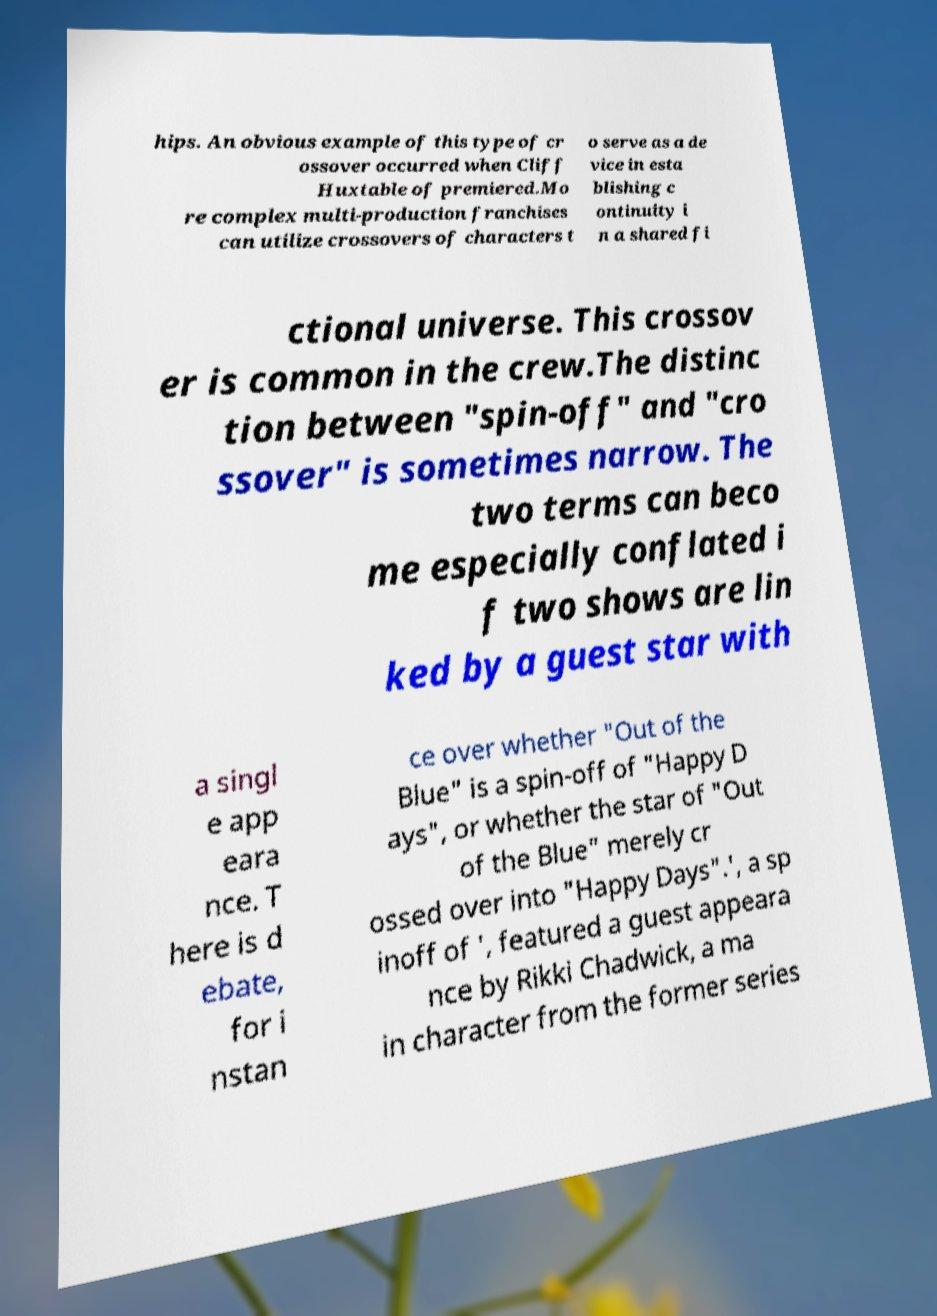I need the written content from this picture converted into text. Can you do that? hips. An obvious example of this type of cr ossover occurred when Cliff Huxtable of premiered.Mo re complex multi-production franchises can utilize crossovers of characters t o serve as a de vice in esta blishing c ontinuity i n a shared fi ctional universe. This crossov er is common in the crew.The distinc tion between "spin-off" and "cro ssover" is sometimes narrow. The two terms can beco me especially conflated i f two shows are lin ked by a guest star with a singl e app eara nce. T here is d ebate, for i nstan ce over whether "Out of the Blue" is a spin-off of "Happy D ays", or whether the star of "Out of the Blue" merely cr ossed over into "Happy Days".', a sp inoff of ', featured a guest appeara nce by Rikki Chadwick, a ma in character from the former series 